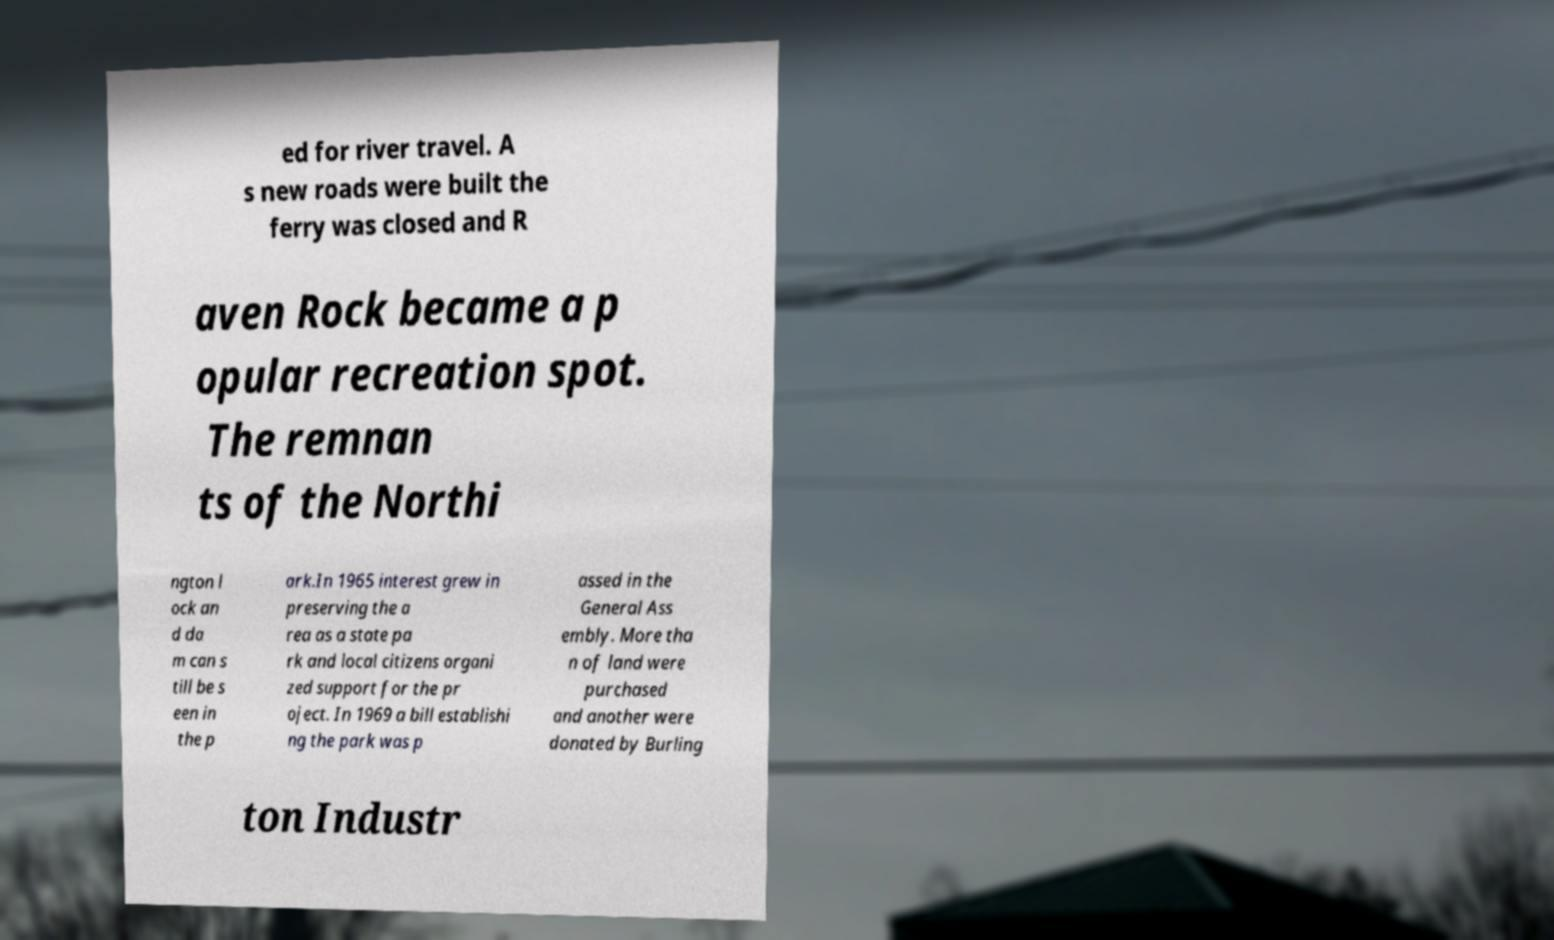What messages or text are displayed in this image? I need them in a readable, typed format. ed for river travel. A s new roads were built the ferry was closed and R aven Rock became a p opular recreation spot. The remnan ts of the Northi ngton l ock an d da m can s till be s een in the p ark.In 1965 interest grew in preserving the a rea as a state pa rk and local citizens organi zed support for the pr oject. In 1969 a bill establishi ng the park was p assed in the General Ass embly. More tha n of land were purchased and another were donated by Burling ton Industr 